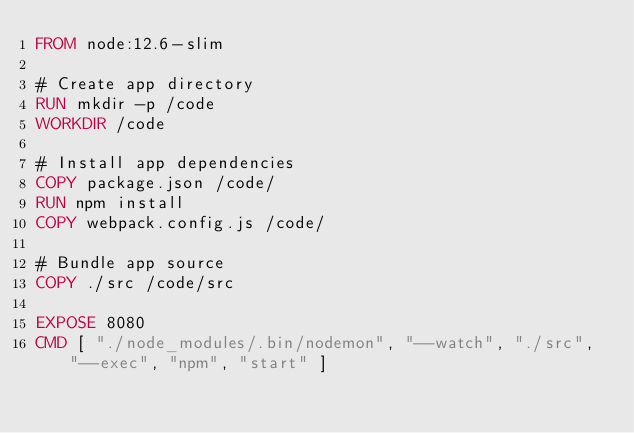Convert code to text. <code><loc_0><loc_0><loc_500><loc_500><_Dockerfile_>FROM node:12.6-slim

# Create app directory
RUN mkdir -p /code
WORKDIR /code

# Install app dependencies
COPY package.json /code/
RUN npm install
COPY webpack.config.js /code/

# Bundle app source
COPY ./src /code/src

EXPOSE 8080
CMD [ "./node_modules/.bin/nodemon", "--watch", "./src", "--exec", "npm", "start" ]</code> 